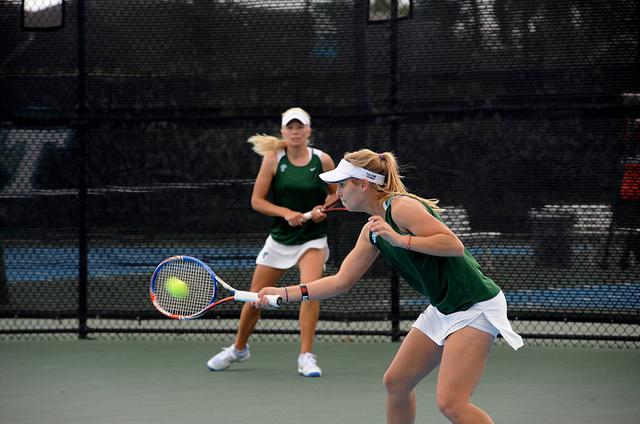Is the woman on the left missing the ball?
Write a very short answer. No. What sport are the girls playing?
Quick response, please. Tennis. What color is the closer woman's visor?
Quick response, please. White. What is the girl hitting the ball with?
Write a very short answer. Racket. What color is the fence behind the girls?
Quick response, please. Black. 